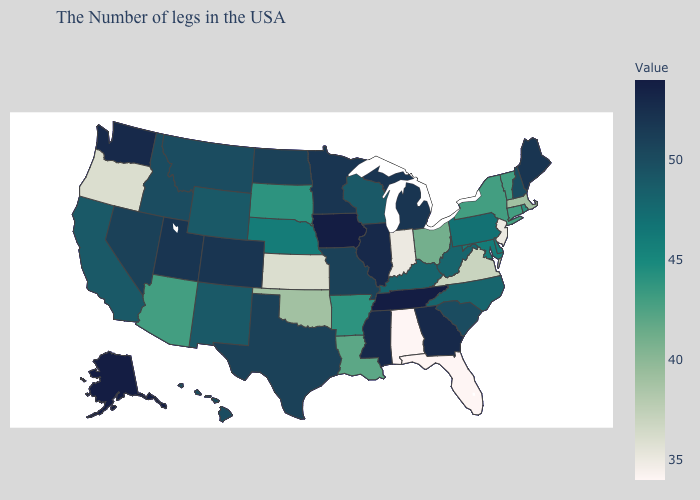Does Oklahoma have a higher value than Alabama?
Answer briefly. Yes. Which states have the lowest value in the USA?
Write a very short answer. Florida, Alabama. Does the map have missing data?
Quick response, please. No. Does Tennessee have the highest value in the USA?
Give a very brief answer. Yes. Does Vermont have the highest value in the Northeast?
Concise answer only. No. Among the states that border Nevada , does Utah have the lowest value?
Short answer required. No. Does Wyoming have a higher value than Arkansas?
Concise answer only. Yes. 